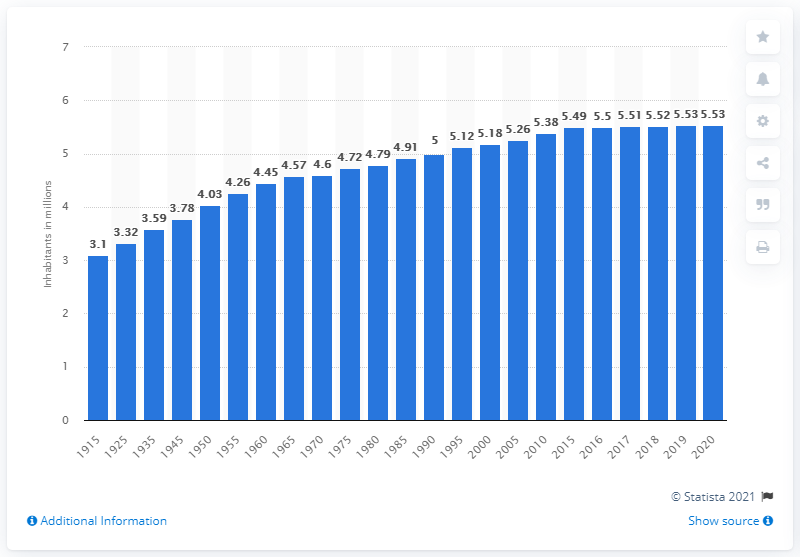Give some essential details in this illustration. In 1990, the population of Finland was approximately 5.53 million. In 2020, the population of Finland was approximately 5.53 million. 